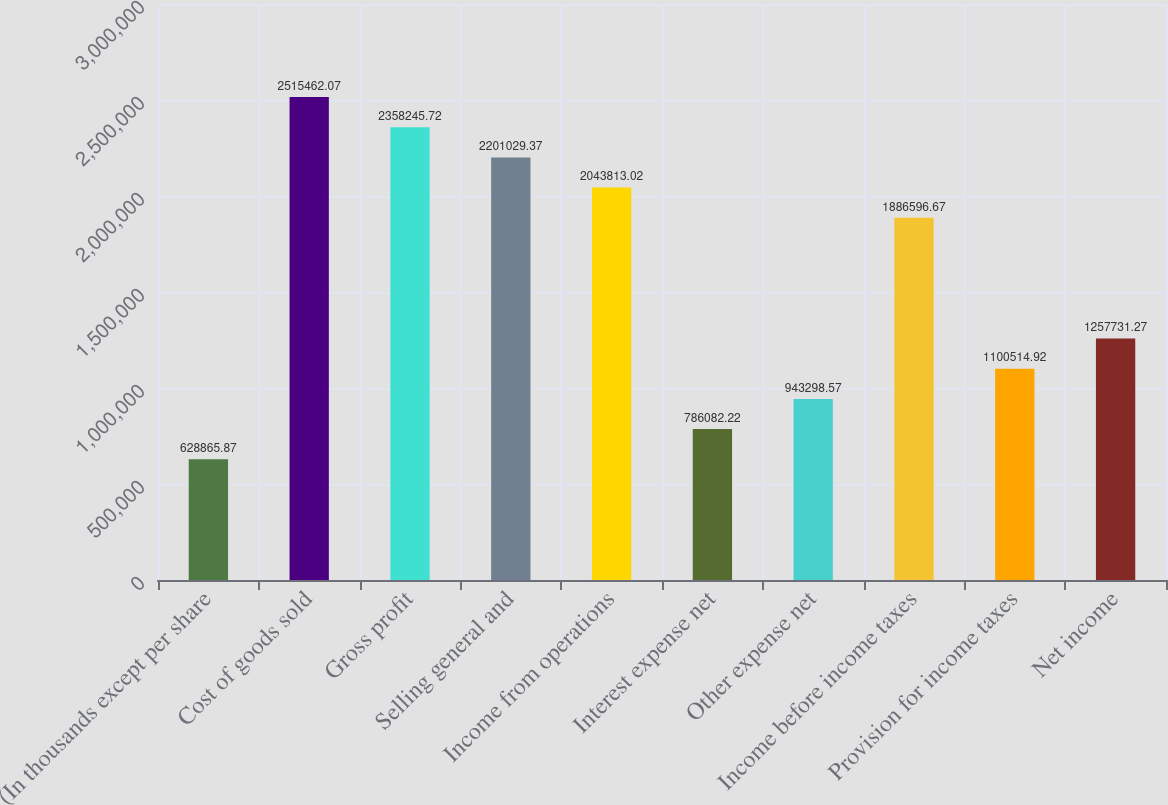Convert chart. <chart><loc_0><loc_0><loc_500><loc_500><bar_chart><fcel>(In thousands except per share<fcel>Cost of goods sold<fcel>Gross profit<fcel>Selling general and<fcel>Income from operations<fcel>Interest expense net<fcel>Other expense net<fcel>Income before income taxes<fcel>Provision for income taxes<fcel>Net income<nl><fcel>628866<fcel>2.51546e+06<fcel>2.35825e+06<fcel>2.20103e+06<fcel>2.04381e+06<fcel>786082<fcel>943299<fcel>1.8866e+06<fcel>1.10051e+06<fcel>1.25773e+06<nl></chart> 